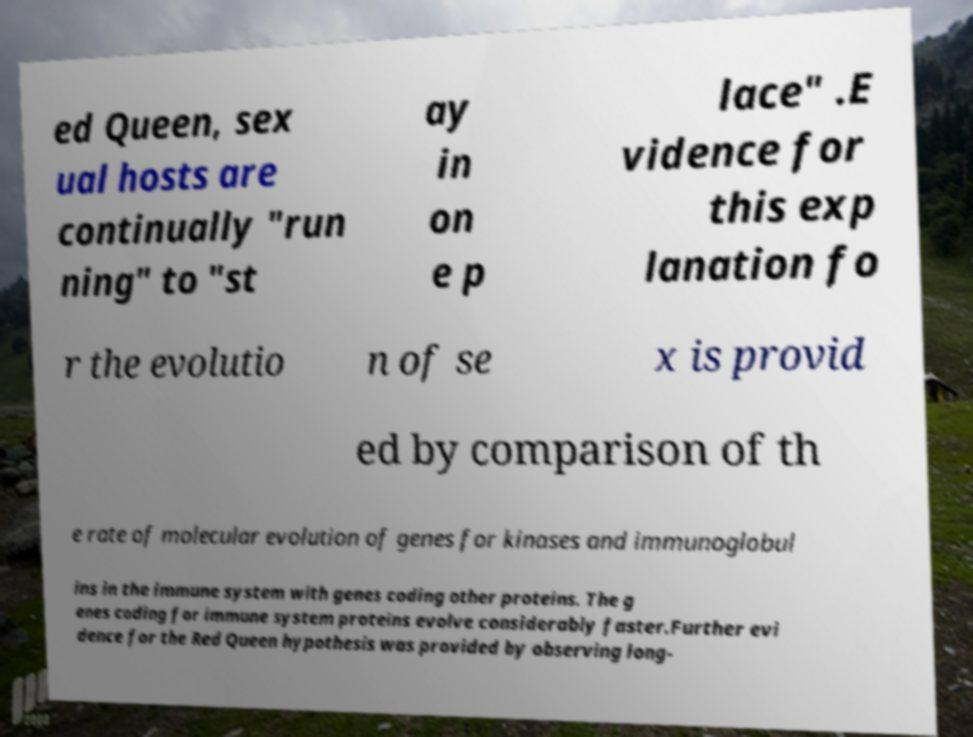For documentation purposes, I need the text within this image transcribed. Could you provide that? ed Queen, sex ual hosts are continually "run ning" to "st ay in on e p lace" .E vidence for this exp lanation fo r the evolutio n of se x is provid ed by comparison of th e rate of molecular evolution of genes for kinases and immunoglobul ins in the immune system with genes coding other proteins. The g enes coding for immune system proteins evolve considerably faster.Further evi dence for the Red Queen hypothesis was provided by observing long- 